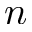<formula> <loc_0><loc_0><loc_500><loc_500>n</formula> 